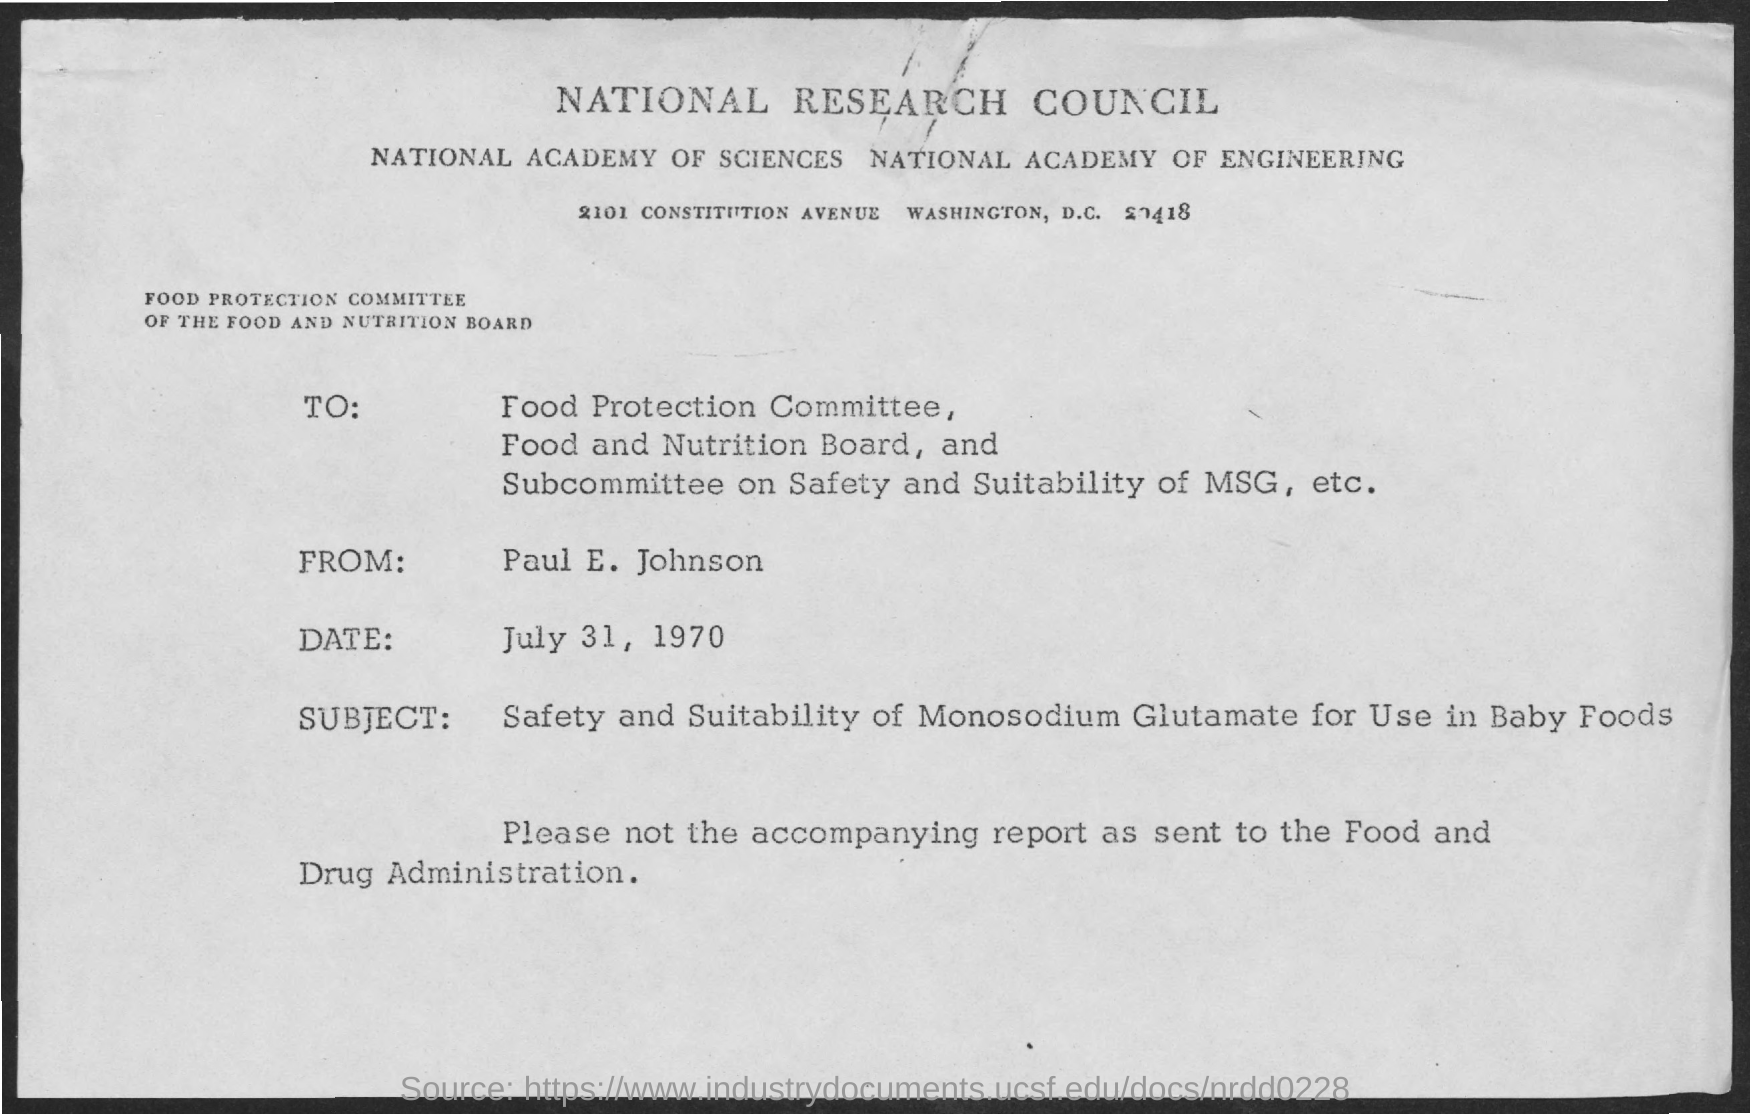Draw attention to some important aspects in this diagram. The National Research Council is the first title in the document. The document states that the date mentioned is July 31, 1970. 